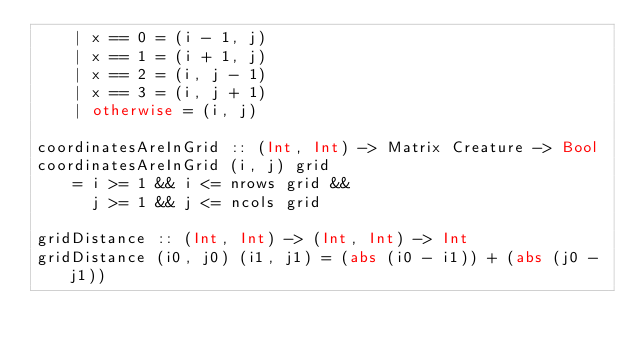<code> <loc_0><loc_0><loc_500><loc_500><_Haskell_>    | x == 0 = (i - 1, j)
    | x == 1 = (i + 1, j)
    | x == 2 = (i, j - 1)
    | x == 3 = (i, j + 1)
    | otherwise = (i, j)

coordinatesAreInGrid :: (Int, Int) -> Matrix Creature -> Bool
coordinatesAreInGrid (i, j) grid
    = i >= 1 && i <= nrows grid &&
      j >= 1 && j <= ncols grid

gridDistance :: (Int, Int) -> (Int, Int) -> Int
gridDistance (i0, j0) (i1, j1) = (abs (i0 - i1)) + (abs (j0 - j1))
</code> 